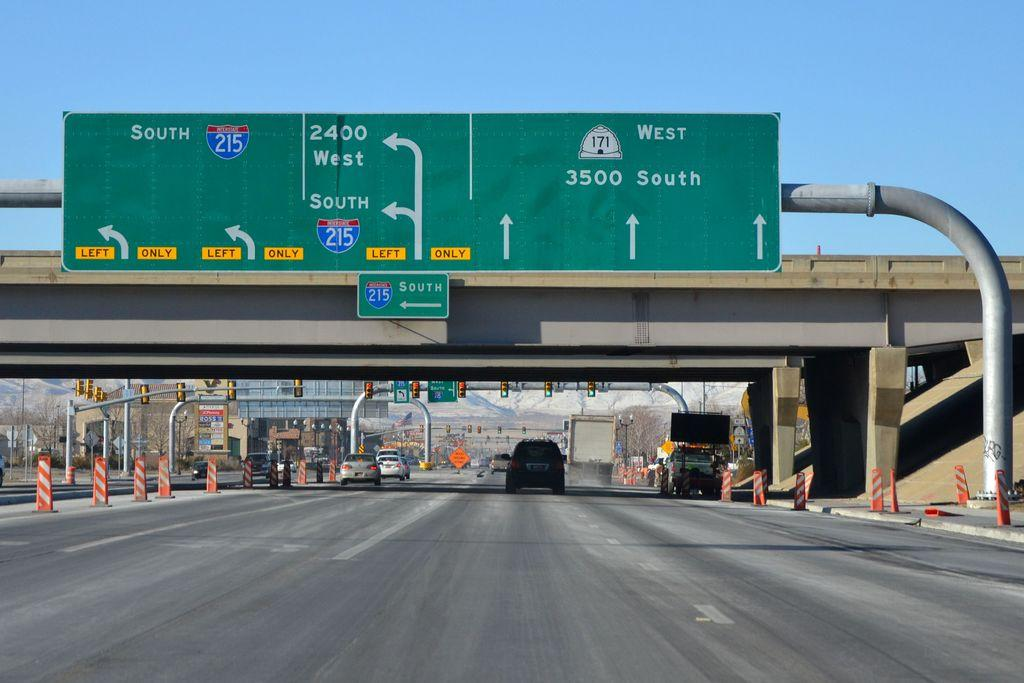<image>
Give a short and clear explanation of the subsequent image. A green sign hangs above an over pass with exits shown for west and south. 